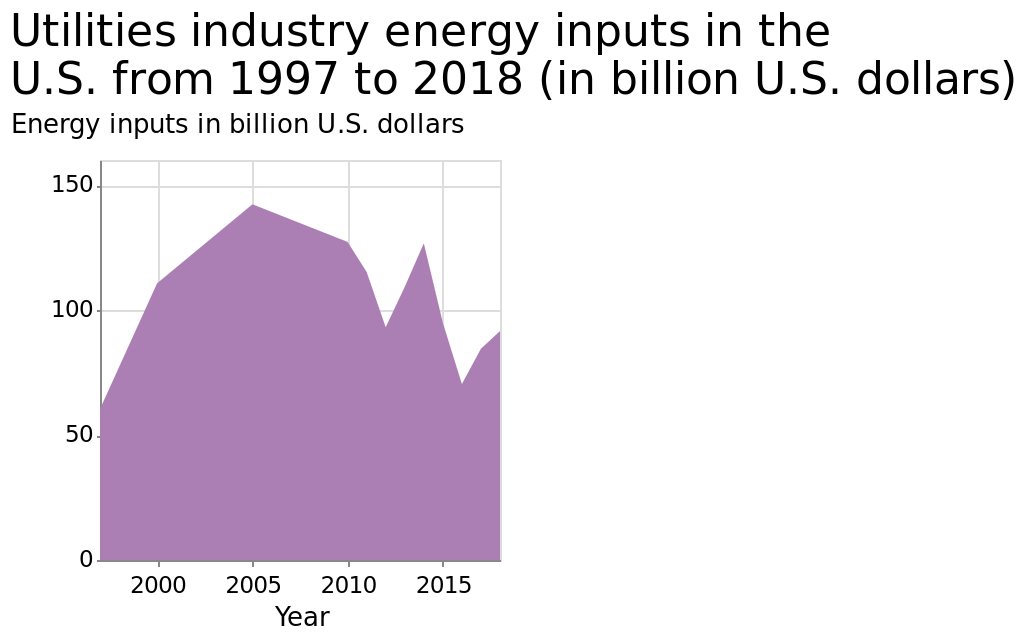<image>
please describe the details of the chart Utilities industry energy inputs in the U.S. from 1997 to 2018 (in billion U.S. dollars) is a area plot. Year is plotted with a linear scale of range 2000 to 2015 along the x-axis. The y-axis shows Energy inputs in billion U.S. dollars with a linear scale with a minimum of 0 and a maximum of 150. What is the range of the x-axis on the plot?  The range of the x-axis on the plot is from 2000 to 2015. When did the energy input reach its peak?  The energy input reached its peak in the year 2005. What is the time span covered by the plot? The plot covers the time period from 1997 to 2018. Does the plot cover the time period from 1997 to 2019? No.The plot covers the time period from 1997 to 2018. 